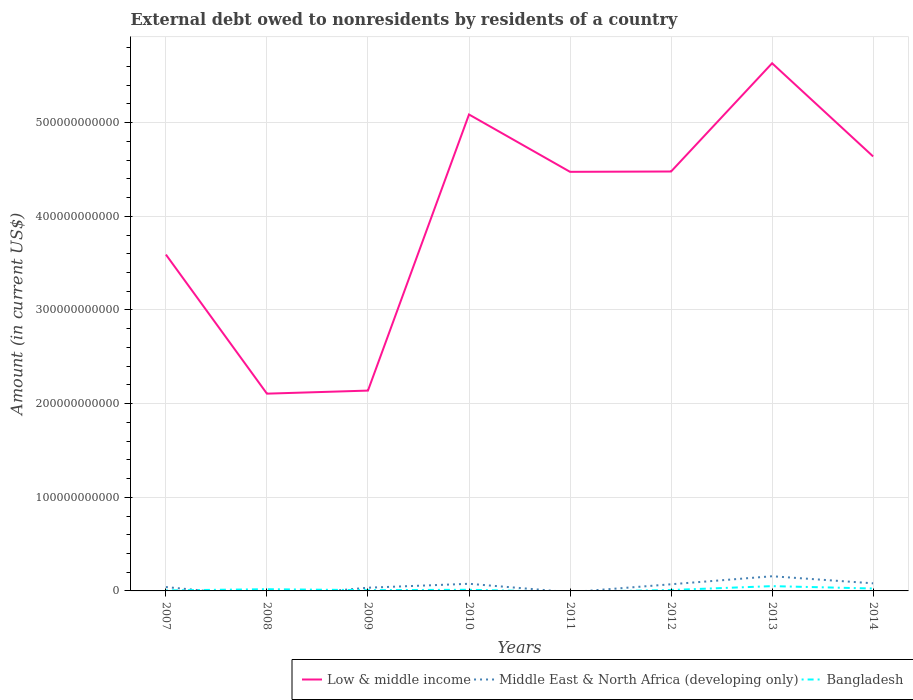How many different coloured lines are there?
Your answer should be compact. 3. Across all years, what is the maximum external debt owed by residents in Low & middle income?
Provide a short and direct response. 2.11e+11. What is the total external debt owed by residents in Low & middle income in the graph?
Ensure brevity in your answer.  -3.50e+11. What is the difference between the highest and the second highest external debt owed by residents in Bangladesh?
Keep it short and to the point. 5.12e+09. Is the external debt owed by residents in Middle East & North Africa (developing only) strictly greater than the external debt owed by residents in Bangladesh over the years?
Offer a terse response. No. How many years are there in the graph?
Keep it short and to the point. 8. What is the difference between two consecutive major ticks on the Y-axis?
Offer a very short reply. 1.00e+11. Does the graph contain grids?
Provide a short and direct response. Yes. How many legend labels are there?
Your answer should be very brief. 3. What is the title of the graph?
Your response must be concise. External debt owed to nonresidents by residents of a country. What is the label or title of the X-axis?
Give a very brief answer. Years. What is the Amount (in current US$) of Low & middle income in 2007?
Make the answer very short. 3.59e+11. What is the Amount (in current US$) of Middle East & North Africa (developing only) in 2007?
Ensure brevity in your answer.  4.12e+09. What is the Amount (in current US$) in Bangladesh in 2007?
Provide a succinct answer. 5.37e+08. What is the Amount (in current US$) in Low & middle income in 2008?
Give a very brief answer. 2.11e+11. What is the Amount (in current US$) of Bangladesh in 2008?
Offer a very short reply. 1.83e+09. What is the Amount (in current US$) in Low & middle income in 2009?
Provide a short and direct response. 2.14e+11. What is the Amount (in current US$) in Middle East & North Africa (developing only) in 2009?
Provide a short and direct response. 3.43e+09. What is the Amount (in current US$) in Bangladesh in 2009?
Your response must be concise. 8.14e+08. What is the Amount (in current US$) of Low & middle income in 2010?
Keep it short and to the point. 5.09e+11. What is the Amount (in current US$) in Middle East & North Africa (developing only) in 2010?
Provide a succinct answer. 7.62e+09. What is the Amount (in current US$) in Bangladesh in 2010?
Your answer should be compact. 1.21e+09. What is the Amount (in current US$) in Low & middle income in 2011?
Provide a succinct answer. 4.48e+11. What is the Amount (in current US$) of Middle East & North Africa (developing only) in 2011?
Provide a succinct answer. 0. What is the Amount (in current US$) of Low & middle income in 2012?
Offer a very short reply. 4.48e+11. What is the Amount (in current US$) of Middle East & North Africa (developing only) in 2012?
Keep it short and to the point. 7.10e+09. What is the Amount (in current US$) in Bangladesh in 2012?
Your answer should be very brief. 9.83e+08. What is the Amount (in current US$) of Low & middle income in 2013?
Keep it short and to the point. 5.63e+11. What is the Amount (in current US$) of Middle East & North Africa (developing only) in 2013?
Offer a very short reply. 1.57e+1. What is the Amount (in current US$) of Bangladesh in 2013?
Your answer should be very brief. 5.12e+09. What is the Amount (in current US$) in Low & middle income in 2014?
Provide a succinct answer. 4.64e+11. What is the Amount (in current US$) in Middle East & North Africa (developing only) in 2014?
Offer a very short reply. 8.10e+09. What is the Amount (in current US$) of Bangladesh in 2014?
Ensure brevity in your answer.  2.57e+09. Across all years, what is the maximum Amount (in current US$) of Low & middle income?
Offer a terse response. 5.63e+11. Across all years, what is the maximum Amount (in current US$) of Middle East & North Africa (developing only)?
Keep it short and to the point. 1.57e+1. Across all years, what is the maximum Amount (in current US$) of Bangladesh?
Make the answer very short. 5.12e+09. Across all years, what is the minimum Amount (in current US$) in Low & middle income?
Your response must be concise. 2.11e+11. Across all years, what is the minimum Amount (in current US$) in Middle East & North Africa (developing only)?
Provide a short and direct response. 0. What is the total Amount (in current US$) of Low & middle income in the graph?
Your answer should be compact. 3.22e+12. What is the total Amount (in current US$) in Middle East & North Africa (developing only) in the graph?
Offer a very short reply. 4.60e+1. What is the total Amount (in current US$) of Bangladesh in the graph?
Your answer should be compact. 1.31e+1. What is the difference between the Amount (in current US$) in Low & middle income in 2007 and that in 2008?
Your answer should be compact. 1.49e+11. What is the difference between the Amount (in current US$) in Bangladesh in 2007 and that in 2008?
Give a very brief answer. -1.29e+09. What is the difference between the Amount (in current US$) in Low & middle income in 2007 and that in 2009?
Your answer should be compact. 1.45e+11. What is the difference between the Amount (in current US$) in Middle East & North Africa (developing only) in 2007 and that in 2009?
Ensure brevity in your answer.  6.89e+08. What is the difference between the Amount (in current US$) in Bangladesh in 2007 and that in 2009?
Your answer should be compact. -2.78e+08. What is the difference between the Amount (in current US$) in Low & middle income in 2007 and that in 2010?
Give a very brief answer. -1.50e+11. What is the difference between the Amount (in current US$) in Middle East & North Africa (developing only) in 2007 and that in 2010?
Your response must be concise. -3.50e+09. What is the difference between the Amount (in current US$) in Bangladesh in 2007 and that in 2010?
Give a very brief answer. -6.72e+08. What is the difference between the Amount (in current US$) of Low & middle income in 2007 and that in 2011?
Offer a very short reply. -8.83e+1. What is the difference between the Amount (in current US$) of Low & middle income in 2007 and that in 2012?
Give a very brief answer. -8.87e+1. What is the difference between the Amount (in current US$) of Middle East & North Africa (developing only) in 2007 and that in 2012?
Provide a short and direct response. -2.98e+09. What is the difference between the Amount (in current US$) of Bangladesh in 2007 and that in 2012?
Make the answer very short. -4.47e+08. What is the difference between the Amount (in current US$) of Low & middle income in 2007 and that in 2013?
Your response must be concise. -2.04e+11. What is the difference between the Amount (in current US$) in Middle East & North Africa (developing only) in 2007 and that in 2013?
Your response must be concise. -1.15e+1. What is the difference between the Amount (in current US$) in Bangladesh in 2007 and that in 2013?
Offer a terse response. -4.58e+09. What is the difference between the Amount (in current US$) in Low & middle income in 2007 and that in 2014?
Make the answer very short. -1.05e+11. What is the difference between the Amount (in current US$) of Middle East & North Africa (developing only) in 2007 and that in 2014?
Keep it short and to the point. -3.98e+09. What is the difference between the Amount (in current US$) of Bangladesh in 2007 and that in 2014?
Ensure brevity in your answer.  -2.03e+09. What is the difference between the Amount (in current US$) of Low & middle income in 2008 and that in 2009?
Offer a very short reply. -3.27e+09. What is the difference between the Amount (in current US$) in Bangladesh in 2008 and that in 2009?
Give a very brief answer. 1.01e+09. What is the difference between the Amount (in current US$) of Low & middle income in 2008 and that in 2010?
Offer a very short reply. -2.98e+11. What is the difference between the Amount (in current US$) in Bangladesh in 2008 and that in 2010?
Provide a succinct answer. 6.19e+08. What is the difference between the Amount (in current US$) in Low & middle income in 2008 and that in 2011?
Ensure brevity in your answer.  -2.37e+11. What is the difference between the Amount (in current US$) in Low & middle income in 2008 and that in 2012?
Ensure brevity in your answer.  -2.37e+11. What is the difference between the Amount (in current US$) in Bangladesh in 2008 and that in 2012?
Ensure brevity in your answer.  8.45e+08. What is the difference between the Amount (in current US$) of Low & middle income in 2008 and that in 2013?
Your answer should be compact. -3.53e+11. What is the difference between the Amount (in current US$) of Bangladesh in 2008 and that in 2013?
Provide a succinct answer. -3.29e+09. What is the difference between the Amount (in current US$) in Low & middle income in 2008 and that in 2014?
Make the answer very short. -2.53e+11. What is the difference between the Amount (in current US$) of Bangladesh in 2008 and that in 2014?
Offer a very short reply. -7.40e+08. What is the difference between the Amount (in current US$) in Low & middle income in 2009 and that in 2010?
Keep it short and to the point. -2.95e+11. What is the difference between the Amount (in current US$) in Middle East & North Africa (developing only) in 2009 and that in 2010?
Give a very brief answer. -4.19e+09. What is the difference between the Amount (in current US$) in Bangladesh in 2009 and that in 2010?
Provide a succinct answer. -3.95e+08. What is the difference between the Amount (in current US$) in Low & middle income in 2009 and that in 2011?
Your response must be concise. -2.34e+11. What is the difference between the Amount (in current US$) in Low & middle income in 2009 and that in 2012?
Keep it short and to the point. -2.34e+11. What is the difference between the Amount (in current US$) of Middle East & North Africa (developing only) in 2009 and that in 2012?
Your answer should be compact. -3.67e+09. What is the difference between the Amount (in current US$) in Bangladesh in 2009 and that in 2012?
Provide a succinct answer. -1.69e+08. What is the difference between the Amount (in current US$) in Low & middle income in 2009 and that in 2013?
Your answer should be compact. -3.50e+11. What is the difference between the Amount (in current US$) of Middle East & North Africa (developing only) in 2009 and that in 2013?
Make the answer very short. -1.22e+1. What is the difference between the Amount (in current US$) in Bangladesh in 2009 and that in 2013?
Ensure brevity in your answer.  -4.30e+09. What is the difference between the Amount (in current US$) of Low & middle income in 2009 and that in 2014?
Provide a short and direct response. -2.50e+11. What is the difference between the Amount (in current US$) of Middle East & North Africa (developing only) in 2009 and that in 2014?
Keep it short and to the point. -4.67e+09. What is the difference between the Amount (in current US$) in Bangladesh in 2009 and that in 2014?
Provide a succinct answer. -1.75e+09. What is the difference between the Amount (in current US$) of Low & middle income in 2010 and that in 2011?
Provide a succinct answer. 6.12e+1. What is the difference between the Amount (in current US$) of Low & middle income in 2010 and that in 2012?
Your answer should be compact. 6.09e+1. What is the difference between the Amount (in current US$) in Middle East & North Africa (developing only) in 2010 and that in 2012?
Provide a short and direct response. 5.18e+08. What is the difference between the Amount (in current US$) of Bangladesh in 2010 and that in 2012?
Your response must be concise. 2.25e+08. What is the difference between the Amount (in current US$) of Low & middle income in 2010 and that in 2013?
Offer a terse response. -5.47e+1. What is the difference between the Amount (in current US$) of Middle East & North Africa (developing only) in 2010 and that in 2013?
Ensure brevity in your answer.  -8.05e+09. What is the difference between the Amount (in current US$) in Bangladesh in 2010 and that in 2013?
Your response must be concise. -3.91e+09. What is the difference between the Amount (in current US$) of Low & middle income in 2010 and that in 2014?
Your response must be concise. 4.48e+1. What is the difference between the Amount (in current US$) in Middle East & North Africa (developing only) in 2010 and that in 2014?
Keep it short and to the point. -4.83e+08. What is the difference between the Amount (in current US$) of Bangladesh in 2010 and that in 2014?
Your response must be concise. -1.36e+09. What is the difference between the Amount (in current US$) of Low & middle income in 2011 and that in 2012?
Your answer should be very brief. -3.46e+08. What is the difference between the Amount (in current US$) in Low & middle income in 2011 and that in 2013?
Ensure brevity in your answer.  -1.16e+11. What is the difference between the Amount (in current US$) of Low & middle income in 2011 and that in 2014?
Give a very brief answer. -1.64e+1. What is the difference between the Amount (in current US$) of Low & middle income in 2012 and that in 2013?
Your answer should be very brief. -1.16e+11. What is the difference between the Amount (in current US$) in Middle East & North Africa (developing only) in 2012 and that in 2013?
Offer a very short reply. -8.57e+09. What is the difference between the Amount (in current US$) in Bangladesh in 2012 and that in 2013?
Your answer should be very brief. -4.13e+09. What is the difference between the Amount (in current US$) in Low & middle income in 2012 and that in 2014?
Provide a succinct answer. -1.61e+1. What is the difference between the Amount (in current US$) of Middle East & North Africa (developing only) in 2012 and that in 2014?
Your response must be concise. -1.00e+09. What is the difference between the Amount (in current US$) of Bangladesh in 2012 and that in 2014?
Offer a terse response. -1.59e+09. What is the difference between the Amount (in current US$) of Low & middle income in 2013 and that in 2014?
Make the answer very short. 9.95e+1. What is the difference between the Amount (in current US$) in Middle East & North Africa (developing only) in 2013 and that in 2014?
Your answer should be very brief. 7.56e+09. What is the difference between the Amount (in current US$) in Bangladesh in 2013 and that in 2014?
Your answer should be very brief. 2.55e+09. What is the difference between the Amount (in current US$) of Low & middle income in 2007 and the Amount (in current US$) of Bangladesh in 2008?
Keep it short and to the point. 3.57e+11. What is the difference between the Amount (in current US$) of Middle East & North Africa (developing only) in 2007 and the Amount (in current US$) of Bangladesh in 2008?
Make the answer very short. 2.29e+09. What is the difference between the Amount (in current US$) of Low & middle income in 2007 and the Amount (in current US$) of Middle East & North Africa (developing only) in 2009?
Your response must be concise. 3.56e+11. What is the difference between the Amount (in current US$) in Low & middle income in 2007 and the Amount (in current US$) in Bangladesh in 2009?
Make the answer very short. 3.58e+11. What is the difference between the Amount (in current US$) in Middle East & North Africa (developing only) in 2007 and the Amount (in current US$) in Bangladesh in 2009?
Provide a short and direct response. 3.31e+09. What is the difference between the Amount (in current US$) in Low & middle income in 2007 and the Amount (in current US$) in Middle East & North Africa (developing only) in 2010?
Offer a very short reply. 3.52e+11. What is the difference between the Amount (in current US$) of Low & middle income in 2007 and the Amount (in current US$) of Bangladesh in 2010?
Your answer should be very brief. 3.58e+11. What is the difference between the Amount (in current US$) in Middle East & North Africa (developing only) in 2007 and the Amount (in current US$) in Bangladesh in 2010?
Provide a succinct answer. 2.91e+09. What is the difference between the Amount (in current US$) in Low & middle income in 2007 and the Amount (in current US$) in Middle East & North Africa (developing only) in 2012?
Make the answer very short. 3.52e+11. What is the difference between the Amount (in current US$) in Low & middle income in 2007 and the Amount (in current US$) in Bangladesh in 2012?
Provide a succinct answer. 3.58e+11. What is the difference between the Amount (in current US$) of Middle East & North Africa (developing only) in 2007 and the Amount (in current US$) of Bangladesh in 2012?
Provide a short and direct response. 3.14e+09. What is the difference between the Amount (in current US$) in Low & middle income in 2007 and the Amount (in current US$) in Middle East & North Africa (developing only) in 2013?
Make the answer very short. 3.43e+11. What is the difference between the Amount (in current US$) of Low & middle income in 2007 and the Amount (in current US$) of Bangladesh in 2013?
Your answer should be compact. 3.54e+11. What is the difference between the Amount (in current US$) in Middle East & North Africa (developing only) in 2007 and the Amount (in current US$) in Bangladesh in 2013?
Offer a very short reply. -9.94e+08. What is the difference between the Amount (in current US$) in Low & middle income in 2007 and the Amount (in current US$) in Middle East & North Africa (developing only) in 2014?
Offer a terse response. 3.51e+11. What is the difference between the Amount (in current US$) of Low & middle income in 2007 and the Amount (in current US$) of Bangladesh in 2014?
Ensure brevity in your answer.  3.57e+11. What is the difference between the Amount (in current US$) of Middle East & North Africa (developing only) in 2007 and the Amount (in current US$) of Bangladesh in 2014?
Keep it short and to the point. 1.55e+09. What is the difference between the Amount (in current US$) in Low & middle income in 2008 and the Amount (in current US$) in Middle East & North Africa (developing only) in 2009?
Your response must be concise. 2.07e+11. What is the difference between the Amount (in current US$) of Low & middle income in 2008 and the Amount (in current US$) of Bangladesh in 2009?
Offer a very short reply. 2.10e+11. What is the difference between the Amount (in current US$) in Low & middle income in 2008 and the Amount (in current US$) in Middle East & North Africa (developing only) in 2010?
Offer a terse response. 2.03e+11. What is the difference between the Amount (in current US$) in Low & middle income in 2008 and the Amount (in current US$) in Bangladesh in 2010?
Provide a short and direct response. 2.09e+11. What is the difference between the Amount (in current US$) in Low & middle income in 2008 and the Amount (in current US$) in Middle East & North Africa (developing only) in 2012?
Your response must be concise. 2.04e+11. What is the difference between the Amount (in current US$) in Low & middle income in 2008 and the Amount (in current US$) in Bangladesh in 2012?
Your answer should be compact. 2.10e+11. What is the difference between the Amount (in current US$) of Low & middle income in 2008 and the Amount (in current US$) of Middle East & North Africa (developing only) in 2013?
Ensure brevity in your answer.  1.95e+11. What is the difference between the Amount (in current US$) of Low & middle income in 2008 and the Amount (in current US$) of Bangladesh in 2013?
Provide a succinct answer. 2.06e+11. What is the difference between the Amount (in current US$) in Low & middle income in 2008 and the Amount (in current US$) in Middle East & North Africa (developing only) in 2014?
Give a very brief answer. 2.03e+11. What is the difference between the Amount (in current US$) in Low & middle income in 2008 and the Amount (in current US$) in Bangladesh in 2014?
Your response must be concise. 2.08e+11. What is the difference between the Amount (in current US$) in Low & middle income in 2009 and the Amount (in current US$) in Middle East & North Africa (developing only) in 2010?
Offer a terse response. 2.06e+11. What is the difference between the Amount (in current US$) of Low & middle income in 2009 and the Amount (in current US$) of Bangladesh in 2010?
Offer a terse response. 2.13e+11. What is the difference between the Amount (in current US$) in Middle East & North Africa (developing only) in 2009 and the Amount (in current US$) in Bangladesh in 2010?
Provide a short and direct response. 2.22e+09. What is the difference between the Amount (in current US$) of Low & middle income in 2009 and the Amount (in current US$) of Middle East & North Africa (developing only) in 2012?
Ensure brevity in your answer.  2.07e+11. What is the difference between the Amount (in current US$) in Low & middle income in 2009 and the Amount (in current US$) in Bangladesh in 2012?
Keep it short and to the point. 2.13e+11. What is the difference between the Amount (in current US$) in Middle East & North Africa (developing only) in 2009 and the Amount (in current US$) in Bangladesh in 2012?
Provide a short and direct response. 2.45e+09. What is the difference between the Amount (in current US$) in Low & middle income in 2009 and the Amount (in current US$) in Middle East & North Africa (developing only) in 2013?
Offer a terse response. 1.98e+11. What is the difference between the Amount (in current US$) in Low & middle income in 2009 and the Amount (in current US$) in Bangladesh in 2013?
Ensure brevity in your answer.  2.09e+11. What is the difference between the Amount (in current US$) of Middle East & North Africa (developing only) in 2009 and the Amount (in current US$) of Bangladesh in 2013?
Provide a short and direct response. -1.68e+09. What is the difference between the Amount (in current US$) of Low & middle income in 2009 and the Amount (in current US$) of Middle East & North Africa (developing only) in 2014?
Keep it short and to the point. 2.06e+11. What is the difference between the Amount (in current US$) in Low & middle income in 2009 and the Amount (in current US$) in Bangladesh in 2014?
Ensure brevity in your answer.  2.11e+11. What is the difference between the Amount (in current US$) of Middle East & North Africa (developing only) in 2009 and the Amount (in current US$) of Bangladesh in 2014?
Your response must be concise. 8.64e+08. What is the difference between the Amount (in current US$) in Low & middle income in 2010 and the Amount (in current US$) in Middle East & North Africa (developing only) in 2012?
Give a very brief answer. 5.02e+11. What is the difference between the Amount (in current US$) in Low & middle income in 2010 and the Amount (in current US$) in Bangladesh in 2012?
Offer a very short reply. 5.08e+11. What is the difference between the Amount (in current US$) of Middle East & North Africa (developing only) in 2010 and the Amount (in current US$) of Bangladesh in 2012?
Give a very brief answer. 6.64e+09. What is the difference between the Amount (in current US$) of Low & middle income in 2010 and the Amount (in current US$) of Middle East & North Africa (developing only) in 2013?
Give a very brief answer. 4.93e+11. What is the difference between the Amount (in current US$) in Low & middle income in 2010 and the Amount (in current US$) in Bangladesh in 2013?
Ensure brevity in your answer.  5.04e+11. What is the difference between the Amount (in current US$) in Middle East & North Africa (developing only) in 2010 and the Amount (in current US$) in Bangladesh in 2013?
Make the answer very short. 2.51e+09. What is the difference between the Amount (in current US$) of Low & middle income in 2010 and the Amount (in current US$) of Middle East & North Africa (developing only) in 2014?
Offer a terse response. 5.01e+11. What is the difference between the Amount (in current US$) of Low & middle income in 2010 and the Amount (in current US$) of Bangladesh in 2014?
Give a very brief answer. 5.06e+11. What is the difference between the Amount (in current US$) of Middle East & North Africa (developing only) in 2010 and the Amount (in current US$) of Bangladesh in 2014?
Your answer should be compact. 5.05e+09. What is the difference between the Amount (in current US$) in Low & middle income in 2011 and the Amount (in current US$) in Middle East & North Africa (developing only) in 2012?
Provide a short and direct response. 4.40e+11. What is the difference between the Amount (in current US$) of Low & middle income in 2011 and the Amount (in current US$) of Bangladesh in 2012?
Offer a very short reply. 4.47e+11. What is the difference between the Amount (in current US$) in Low & middle income in 2011 and the Amount (in current US$) in Middle East & North Africa (developing only) in 2013?
Your answer should be compact. 4.32e+11. What is the difference between the Amount (in current US$) of Low & middle income in 2011 and the Amount (in current US$) of Bangladesh in 2013?
Provide a succinct answer. 4.42e+11. What is the difference between the Amount (in current US$) of Low & middle income in 2011 and the Amount (in current US$) of Middle East & North Africa (developing only) in 2014?
Your answer should be compact. 4.39e+11. What is the difference between the Amount (in current US$) of Low & middle income in 2011 and the Amount (in current US$) of Bangladesh in 2014?
Your answer should be compact. 4.45e+11. What is the difference between the Amount (in current US$) of Low & middle income in 2012 and the Amount (in current US$) of Middle East & North Africa (developing only) in 2013?
Your answer should be very brief. 4.32e+11. What is the difference between the Amount (in current US$) of Low & middle income in 2012 and the Amount (in current US$) of Bangladesh in 2013?
Offer a terse response. 4.43e+11. What is the difference between the Amount (in current US$) of Middle East & North Africa (developing only) in 2012 and the Amount (in current US$) of Bangladesh in 2013?
Provide a succinct answer. 1.99e+09. What is the difference between the Amount (in current US$) in Low & middle income in 2012 and the Amount (in current US$) in Middle East & North Africa (developing only) in 2014?
Keep it short and to the point. 4.40e+11. What is the difference between the Amount (in current US$) of Low & middle income in 2012 and the Amount (in current US$) of Bangladesh in 2014?
Your response must be concise. 4.45e+11. What is the difference between the Amount (in current US$) of Middle East & North Africa (developing only) in 2012 and the Amount (in current US$) of Bangladesh in 2014?
Make the answer very short. 4.53e+09. What is the difference between the Amount (in current US$) in Low & middle income in 2013 and the Amount (in current US$) in Middle East & North Africa (developing only) in 2014?
Offer a terse response. 5.55e+11. What is the difference between the Amount (in current US$) in Low & middle income in 2013 and the Amount (in current US$) in Bangladesh in 2014?
Offer a very short reply. 5.61e+11. What is the difference between the Amount (in current US$) of Middle East & North Africa (developing only) in 2013 and the Amount (in current US$) of Bangladesh in 2014?
Provide a short and direct response. 1.31e+1. What is the average Amount (in current US$) of Low & middle income per year?
Offer a very short reply. 4.02e+11. What is the average Amount (in current US$) of Middle East & North Africa (developing only) per year?
Your response must be concise. 5.76e+09. What is the average Amount (in current US$) in Bangladesh per year?
Your answer should be compact. 1.63e+09. In the year 2007, what is the difference between the Amount (in current US$) of Low & middle income and Amount (in current US$) of Middle East & North Africa (developing only)?
Your answer should be very brief. 3.55e+11. In the year 2007, what is the difference between the Amount (in current US$) of Low & middle income and Amount (in current US$) of Bangladesh?
Your answer should be compact. 3.59e+11. In the year 2007, what is the difference between the Amount (in current US$) in Middle East & North Africa (developing only) and Amount (in current US$) in Bangladesh?
Your answer should be very brief. 3.58e+09. In the year 2008, what is the difference between the Amount (in current US$) in Low & middle income and Amount (in current US$) in Bangladesh?
Keep it short and to the point. 2.09e+11. In the year 2009, what is the difference between the Amount (in current US$) of Low & middle income and Amount (in current US$) of Middle East & North Africa (developing only)?
Offer a very short reply. 2.10e+11. In the year 2009, what is the difference between the Amount (in current US$) in Low & middle income and Amount (in current US$) in Bangladesh?
Offer a terse response. 2.13e+11. In the year 2009, what is the difference between the Amount (in current US$) of Middle East & North Africa (developing only) and Amount (in current US$) of Bangladesh?
Your answer should be compact. 2.62e+09. In the year 2010, what is the difference between the Amount (in current US$) in Low & middle income and Amount (in current US$) in Middle East & North Africa (developing only)?
Offer a very short reply. 5.01e+11. In the year 2010, what is the difference between the Amount (in current US$) of Low & middle income and Amount (in current US$) of Bangladesh?
Provide a short and direct response. 5.08e+11. In the year 2010, what is the difference between the Amount (in current US$) in Middle East & North Africa (developing only) and Amount (in current US$) in Bangladesh?
Give a very brief answer. 6.41e+09. In the year 2012, what is the difference between the Amount (in current US$) in Low & middle income and Amount (in current US$) in Middle East & North Africa (developing only)?
Offer a terse response. 4.41e+11. In the year 2012, what is the difference between the Amount (in current US$) in Low & middle income and Amount (in current US$) in Bangladesh?
Provide a short and direct response. 4.47e+11. In the year 2012, what is the difference between the Amount (in current US$) in Middle East & North Africa (developing only) and Amount (in current US$) in Bangladesh?
Give a very brief answer. 6.12e+09. In the year 2013, what is the difference between the Amount (in current US$) in Low & middle income and Amount (in current US$) in Middle East & North Africa (developing only)?
Keep it short and to the point. 5.48e+11. In the year 2013, what is the difference between the Amount (in current US$) in Low & middle income and Amount (in current US$) in Bangladesh?
Keep it short and to the point. 5.58e+11. In the year 2013, what is the difference between the Amount (in current US$) of Middle East & North Africa (developing only) and Amount (in current US$) of Bangladesh?
Provide a short and direct response. 1.06e+1. In the year 2014, what is the difference between the Amount (in current US$) of Low & middle income and Amount (in current US$) of Middle East & North Africa (developing only)?
Make the answer very short. 4.56e+11. In the year 2014, what is the difference between the Amount (in current US$) in Low & middle income and Amount (in current US$) in Bangladesh?
Your answer should be compact. 4.61e+11. In the year 2014, what is the difference between the Amount (in current US$) of Middle East & North Africa (developing only) and Amount (in current US$) of Bangladesh?
Keep it short and to the point. 5.53e+09. What is the ratio of the Amount (in current US$) of Low & middle income in 2007 to that in 2008?
Ensure brevity in your answer.  1.71. What is the ratio of the Amount (in current US$) of Bangladesh in 2007 to that in 2008?
Keep it short and to the point. 0.29. What is the ratio of the Amount (in current US$) of Low & middle income in 2007 to that in 2009?
Give a very brief answer. 1.68. What is the ratio of the Amount (in current US$) of Middle East & North Africa (developing only) in 2007 to that in 2009?
Your response must be concise. 1.2. What is the ratio of the Amount (in current US$) in Bangladesh in 2007 to that in 2009?
Your answer should be compact. 0.66. What is the ratio of the Amount (in current US$) of Low & middle income in 2007 to that in 2010?
Keep it short and to the point. 0.71. What is the ratio of the Amount (in current US$) of Middle East & North Africa (developing only) in 2007 to that in 2010?
Offer a terse response. 0.54. What is the ratio of the Amount (in current US$) of Bangladesh in 2007 to that in 2010?
Give a very brief answer. 0.44. What is the ratio of the Amount (in current US$) of Low & middle income in 2007 to that in 2011?
Give a very brief answer. 0.8. What is the ratio of the Amount (in current US$) of Low & middle income in 2007 to that in 2012?
Offer a terse response. 0.8. What is the ratio of the Amount (in current US$) of Middle East & North Africa (developing only) in 2007 to that in 2012?
Keep it short and to the point. 0.58. What is the ratio of the Amount (in current US$) in Bangladesh in 2007 to that in 2012?
Ensure brevity in your answer.  0.55. What is the ratio of the Amount (in current US$) in Low & middle income in 2007 to that in 2013?
Make the answer very short. 0.64. What is the ratio of the Amount (in current US$) of Middle East & North Africa (developing only) in 2007 to that in 2013?
Your answer should be very brief. 0.26. What is the ratio of the Amount (in current US$) in Bangladesh in 2007 to that in 2013?
Give a very brief answer. 0.1. What is the ratio of the Amount (in current US$) in Low & middle income in 2007 to that in 2014?
Ensure brevity in your answer.  0.77. What is the ratio of the Amount (in current US$) in Middle East & North Africa (developing only) in 2007 to that in 2014?
Your response must be concise. 0.51. What is the ratio of the Amount (in current US$) in Bangladesh in 2007 to that in 2014?
Make the answer very short. 0.21. What is the ratio of the Amount (in current US$) of Low & middle income in 2008 to that in 2009?
Your response must be concise. 0.98. What is the ratio of the Amount (in current US$) of Bangladesh in 2008 to that in 2009?
Your answer should be very brief. 2.25. What is the ratio of the Amount (in current US$) of Low & middle income in 2008 to that in 2010?
Provide a short and direct response. 0.41. What is the ratio of the Amount (in current US$) of Bangladesh in 2008 to that in 2010?
Ensure brevity in your answer.  1.51. What is the ratio of the Amount (in current US$) of Low & middle income in 2008 to that in 2011?
Your answer should be compact. 0.47. What is the ratio of the Amount (in current US$) in Low & middle income in 2008 to that in 2012?
Make the answer very short. 0.47. What is the ratio of the Amount (in current US$) in Bangladesh in 2008 to that in 2012?
Your answer should be compact. 1.86. What is the ratio of the Amount (in current US$) in Low & middle income in 2008 to that in 2013?
Your answer should be compact. 0.37. What is the ratio of the Amount (in current US$) in Bangladesh in 2008 to that in 2013?
Your answer should be very brief. 0.36. What is the ratio of the Amount (in current US$) in Low & middle income in 2008 to that in 2014?
Offer a very short reply. 0.45. What is the ratio of the Amount (in current US$) of Bangladesh in 2008 to that in 2014?
Your answer should be very brief. 0.71. What is the ratio of the Amount (in current US$) of Low & middle income in 2009 to that in 2010?
Your response must be concise. 0.42. What is the ratio of the Amount (in current US$) of Middle East & North Africa (developing only) in 2009 to that in 2010?
Offer a very short reply. 0.45. What is the ratio of the Amount (in current US$) of Bangladesh in 2009 to that in 2010?
Offer a terse response. 0.67. What is the ratio of the Amount (in current US$) in Low & middle income in 2009 to that in 2011?
Your response must be concise. 0.48. What is the ratio of the Amount (in current US$) in Low & middle income in 2009 to that in 2012?
Make the answer very short. 0.48. What is the ratio of the Amount (in current US$) of Middle East & North Africa (developing only) in 2009 to that in 2012?
Make the answer very short. 0.48. What is the ratio of the Amount (in current US$) in Bangladesh in 2009 to that in 2012?
Give a very brief answer. 0.83. What is the ratio of the Amount (in current US$) in Low & middle income in 2009 to that in 2013?
Make the answer very short. 0.38. What is the ratio of the Amount (in current US$) in Middle East & North Africa (developing only) in 2009 to that in 2013?
Provide a succinct answer. 0.22. What is the ratio of the Amount (in current US$) of Bangladesh in 2009 to that in 2013?
Make the answer very short. 0.16. What is the ratio of the Amount (in current US$) of Low & middle income in 2009 to that in 2014?
Your response must be concise. 0.46. What is the ratio of the Amount (in current US$) in Middle East & North Africa (developing only) in 2009 to that in 2014?
Offer a very short reply. 0.42. What is the ratio of the Amount (in current US$) of Bangladesh in 2009 to that in 2014?
Make the answer very short. 0.32. What is the ratio of the Amount (in current US$) in Low & middle income in 2010 to that in 2011?
Give a very brief answer. 1.14. What is the ratio of the Amount (in current US$) of Low & middle income in 2010 to that in 2012?
Give a very brief answer. 1.14. What is the ratio of the Amount (in current US$) in Middle East & North Africa (developing only) in 2010 to that in 2012?
Offer a terse response. 1.07. What is the ratio of the Amount (in current US$) in Bangladesh in 2010 to that in 2012?
Your answer should be very brief. 1.23. What is the ratio of the Amount (in current US$) in Low & middle income in 2010 to that in 2013?
Offer a terse response. 0.9. What is the ratio of the Amount (in current US$) in Middle East & North Africa (developing only) in 2010 to that in 2013?
Provide a succinct answer. 0.49. What is the ratio of the Amount (in current US$) of Bangladesh in 2010 to that in 2013?
Your answer should be compact. 0.24. What is the ratio of the Amount (in current US$) in Low & middle income in 2010 to that in 2014?
Make the answer very short. 1.1. What is the ratio of the Amount (in current US$) in Middle East & North Africa (developing only) in 2010 to that in 2014?
Provide a short and direct response. 0.94. What is the ratio of the Amount (in current US$) of Bangladesh in 2010 to that in 2014?
Your answer should be compact. 0.47. What is the ratio of the Amount (in current US$) in Low & middle income in 2011 to that in 2013?
Ensure brevity in your answer.  0.79. What is the ratio of the Amount (in current US$) of Low & middle income in 2011 to that in 2014?
Make the answer very short. 0.96. What is the ratio of the Amount (in current US$) in Low & middle income in 2012 to that in 2013?
Provide a succinct answer. 0.79. What is the ratio of the Amount (in current US$) of Middle East & North Africa (developing only) in 2012 to that in 2013?
Your response must be concise. 0.45. What is the ratio of the Amount (in current US$) of Bangladesh in 2012 to that in 2013?
Offer a terse response. 0.19. What is the ratio of the Amount (in current US$) of Low & middle income in 2012 to that in 2014?
Make the answer very short. 0.97. What is the ratio of the Amount (in current US$) in Middle East & North Africa (developing only) in 2012 to that in 2014?
Offer a terse response. 0.88. What is the ratio of the Amount (in current US$) in Bangladesh in 2012 to that in 2014?
Your answer should be compact. 0.38. What is the ratio of the Amount (in current US$) of Low & middle income in 2013 to that in 2014?
Ensure brevity in your answer.  1.21. What is the ratio of the Amount (in current US$) in Middle East & North Africa (developing only) in 2013 to that in 2014?
Your answer should be very brief. 1.93. What is the ratio of the Amount (in current US$) in Bangladesh in 2013 to that in 2014?
Your answer should be compact. 1.99. What is the difference between the highest and the second highest Amount (in current US$) of Low & middle income?
Offer a very short reply. 5.47e+1. What is the difference between the highest and the second highest Amount (in current US$) in Middle East & North Africa (developing only)?
Ensure brevity in your answer.  7.56e+09. What is the difference between the highest and the second highest Amount (in current US$) in Bangladesh?
Offer a very short reply. 2.55e+09. What is the difference between the highest and the lowest Amount (in current US$) of Low & middle income?
Offer a terse response. 3.53e+11. What is the difference between the highest and the lowest Amount (in current US$) in Middle East & North Africa (developing only)?
Provide a succinct answer. 1.57e+1. What is the difference between the highest and the lowest Amount (in current US$) of Bangladesh?
Your answer should be very brief. 5.12e+09. 